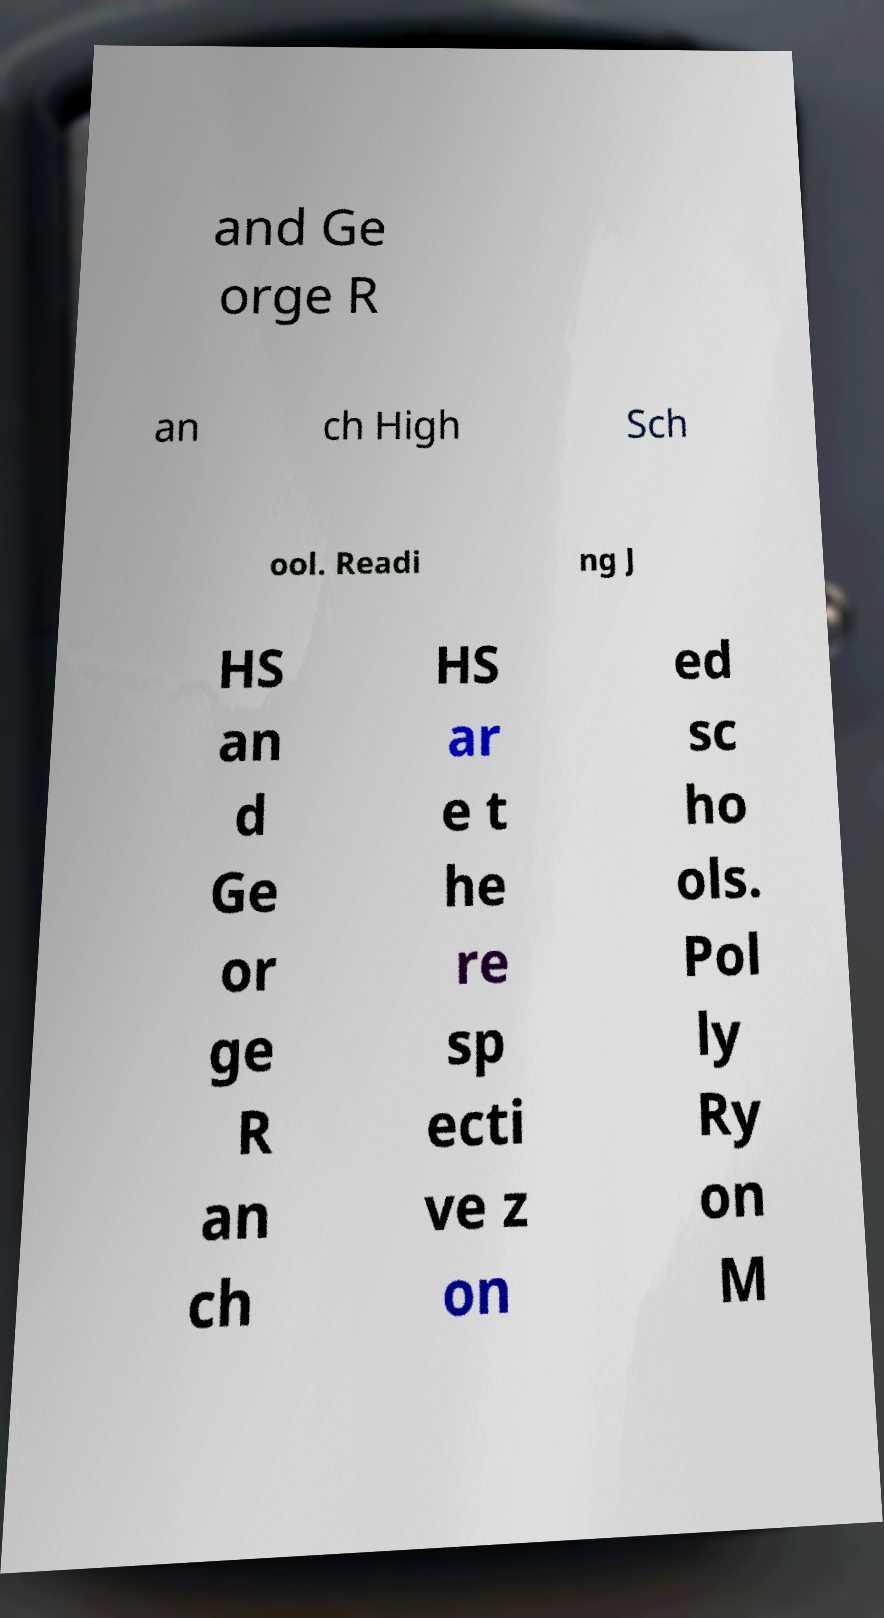Can you accurately transcribe the text from the provided image for me? and Ge orge R an ch High Sch ool. Readi ng J HS an d Ge or ge R an ch HS ar e t he re sp ecti ve z on ed sc ho ols. Pol ly Ry on M 